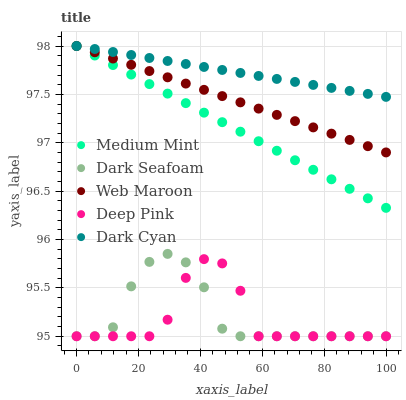Does Deep Pink have the minimum area under the curve?
Answer yes or no. Yes. Does Dark Cyan have the maximum area under the curve?
Answer yes or no. Yes. Does Dark Seafoam have the minimum area under the curve?
Answer yes or no. No. Does Dark Seafoam have the maximum area under the curve?
Answer yes or no. No. Is Medium Mint the smoothest?
Answer yes or no. Yes. Is Deep Pink the roughest?
Answer yes or no. Yes. Is Dark Cyan the smoothest?
Answer yes or no. No. Is Dark Cyan the roughest?
Answer yes or no. No. Does Dark Seafoam have the lowest value?
Answer yes or no. Yes. Does Dark Cyan have the lowest value?
Answer yes or no. No. Does Web Maroon have the highest value?
Answer yes or no. Yes. Does Dark Seafoam have the highest value?
Answer yes or no. No. Is Deep Pink less than Dark Cyan?
Answer yes or no. Yes. Is Medium Mint greater than Deep Pink?
Answer yes or no. Yes. Does Dark Seafoam intersect Deep Pink?
Answer yes or no. Yes. Is Dark Seafoam less than Deep Pink?
Answer yes or no. No. Is Dark Seafoam greater than Deep Pink?
Answer yes or no. No. Does Deep Pink intersect Dark Cyan?
Answer yes or no. No. 